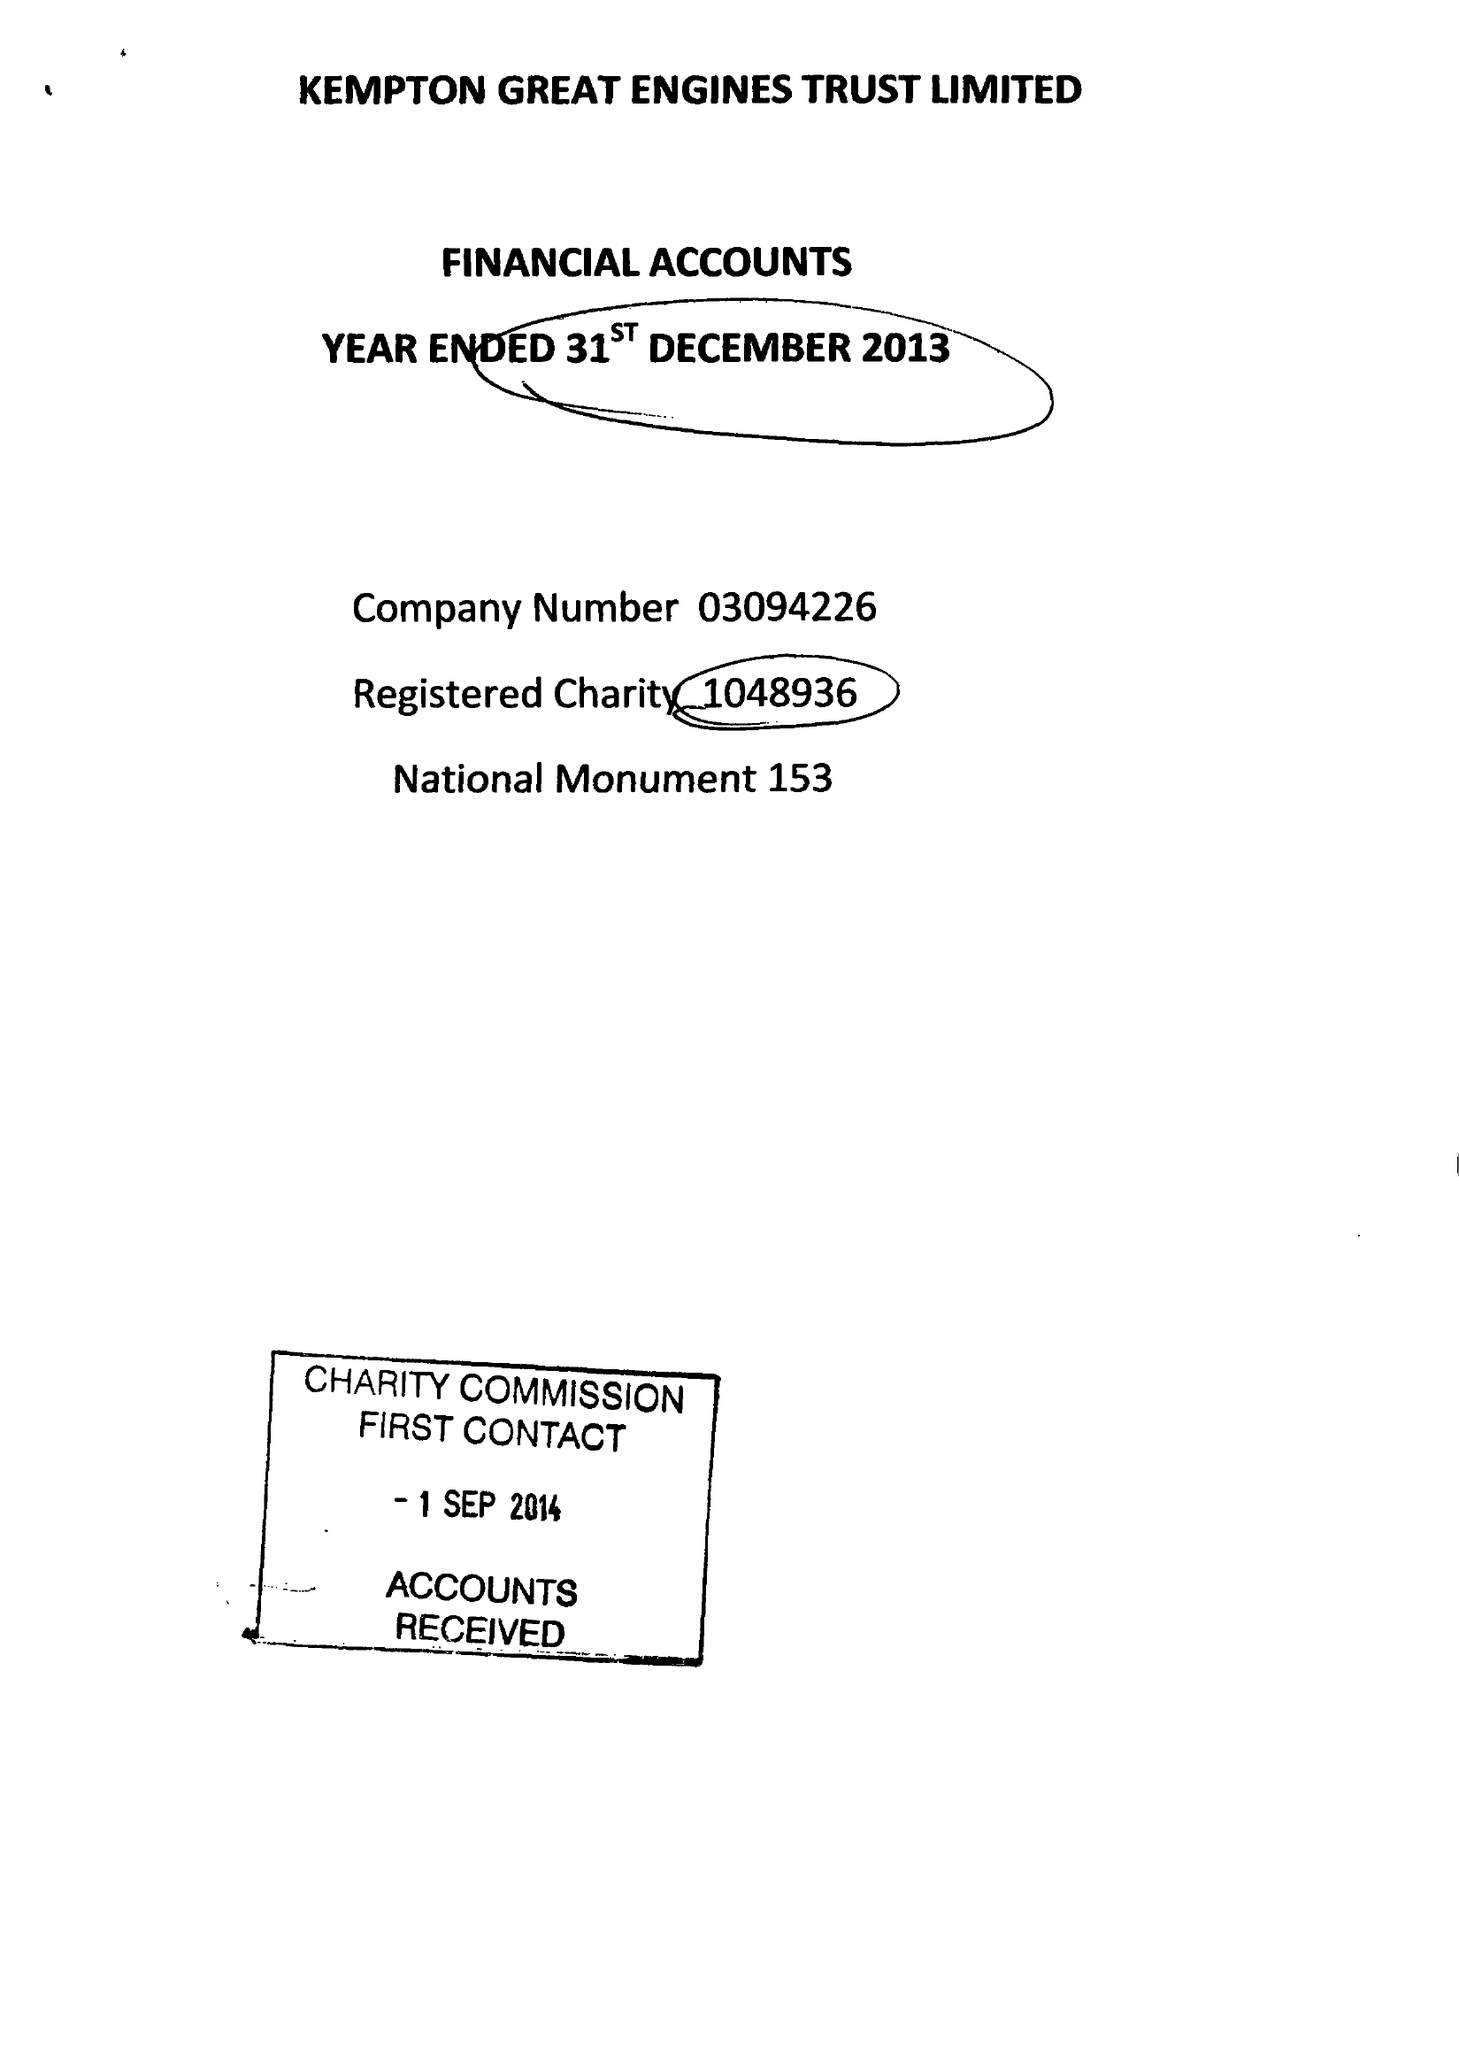What is the value for the spending_annually_in_british_pounds?
Answer the question using a single word or phrase. 53833.00 